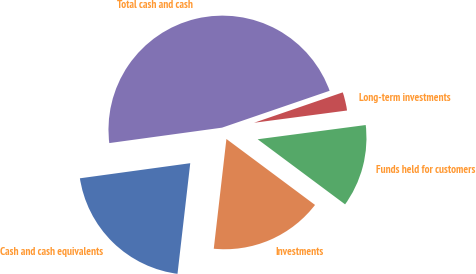Convert chart. <chart><loc_0><loc_0><loc_500><loc_500><pie_chart><fcel>Cash and cash equivalents<fcel>Investments<fcel>Funds held for customers<fcel>Long-term investments<fcel>Total cash and cash<nl><fcel>21.01%<fcel>16.64%<fcel>12.27%<fcel>3.17%<fcel>46.91%<nl></chart> 